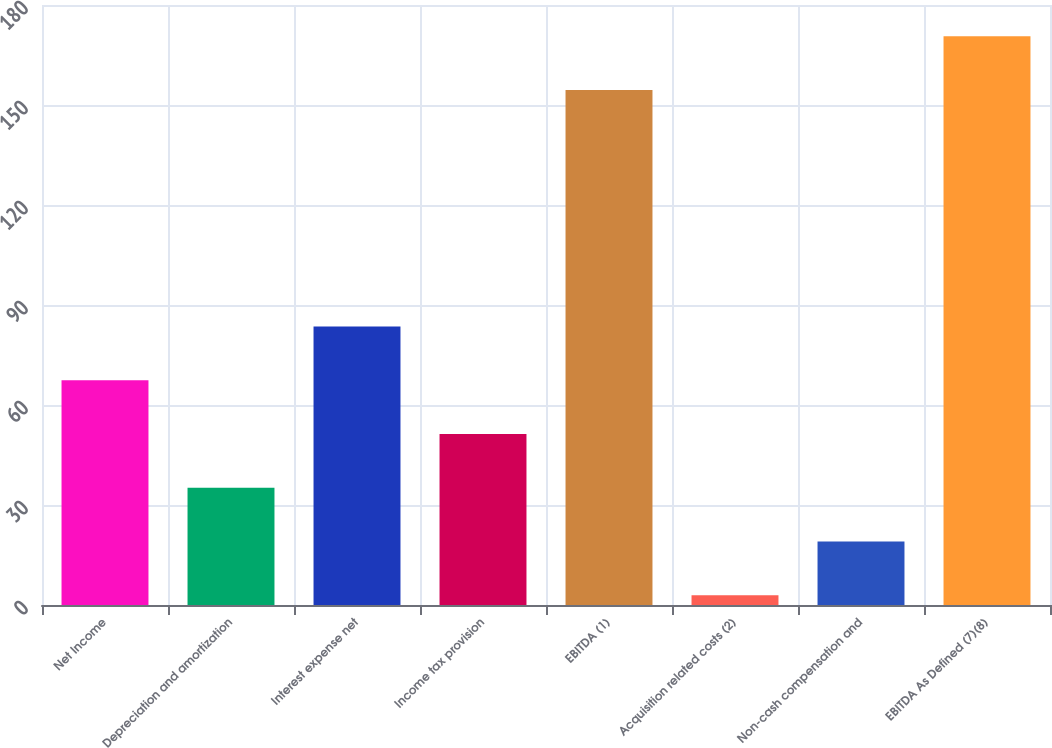<chart> <loc_0><loc_0><loc_500><loc_500><bar_chart><fcel>Net Income<fcel>Depreciation and amortization<fcel>Interest expense net<fcel>Income tax provision<fcel>EBITDA (1)<fcel>Acquisition related costs (2)<fcel>Non-cash compensation and<fcel>EBITDA As Defined (7)(8)<nl><fcel>67.42<fcel>35.16<fcel>83.55<fcel>51.29<fcel>154.5<fcel>2.9<fcel>19.03<fcel>170.63<nl></chart> 